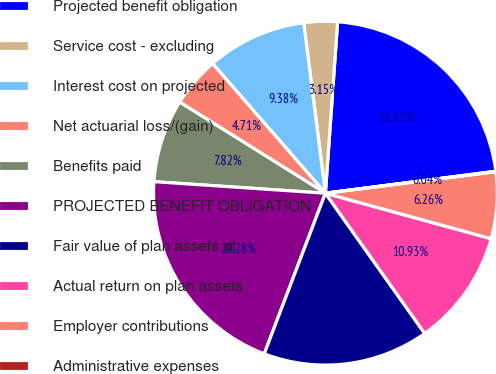<chart> <loc_0><loc_0><loc_500><loc_500><pie_chart><fcel>Projected benefit obligation<fcel>Service cost - excluding<fcel>Interest cost on projected<fcel>Net actuarial loss/(gain)<fcel>Benefits paid<fcel>PROJECTED BENEFIT OBLIGATION<fcel>Fair value of plan assets at<fcel>Actual return on plan assets<fcel>Employer contributions<fcel>Administrative expenses<nl><fcel>21.83%<fcel>3.15%<fcel>9.38%<fcel>4.71%<fcel>7.82%<fcel>20.28%<fcel>15.6%<fcel>10.93%<fcel>6.26%<fcel>0.04%<nl></chart> 